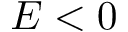Convert formula to latex. <formula><loc_0><loc_0><loc_500><loc_500>E < 0</formula> 